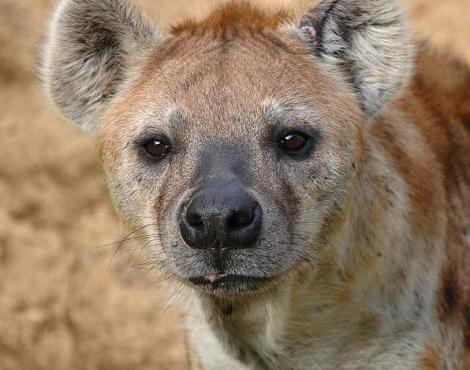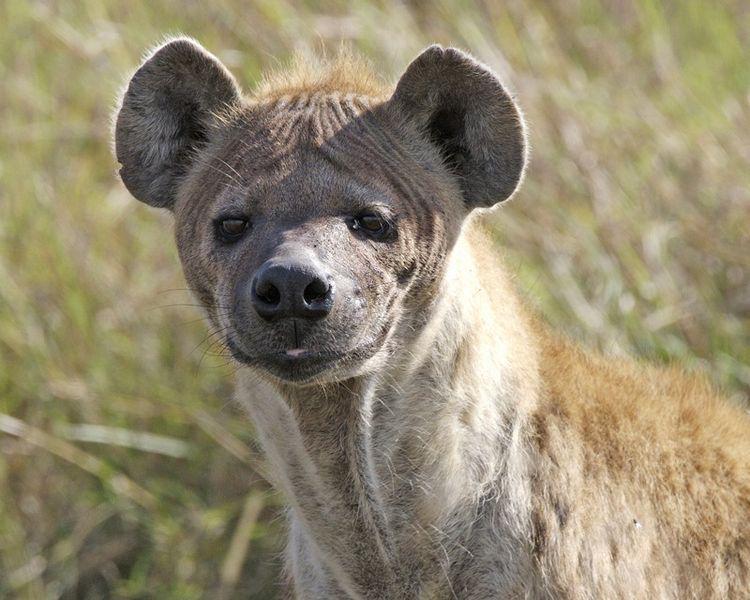The first image is the image on the left, the second image is the image on the right. Evaluate the accuracy of this statement regarding the images: "The left and right image contains the same number of hyenas.". Is it true? Answer yes or no. Yes. The first image is the image on the left, the second image is the image on the right. Analyze the images presented: Is the assertion "Neither image in the pair shows a hyena with it's mouth opened and teeth exposed." valid? Answer yes or no. Yes. 